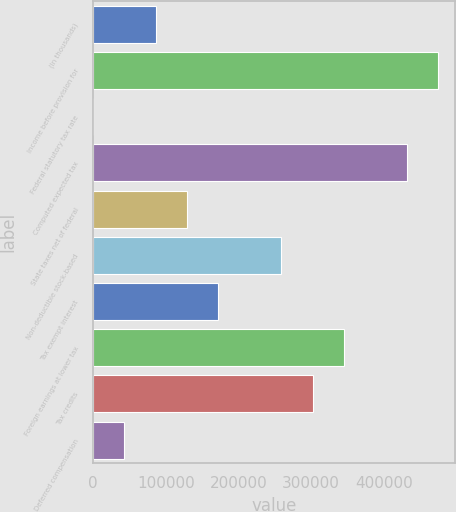Convert chart to OTSL. <chart><loc_0><loc_0><loc_500><loc_500><bar_chart><fcel>(In thousands)<fcel>Income before provision for<fcel>Federal statutory tax rate<fcel>Computed expected tax<fcel>State taxes net of federal<fcel>Non-deductible stock-based<fcel>Tax exempt interest<fcel>Foreign earnings at lower tax<fcel>Tax credits<fcel>Deferred compensation<nl><fcel>86257.2<fcel>474257<fcel>35<fcel>431146<fcel>129368<fcel>258702<fcel>172479<fcel>344924<fcel>301813<fcel>43146.1<nl></chart> 